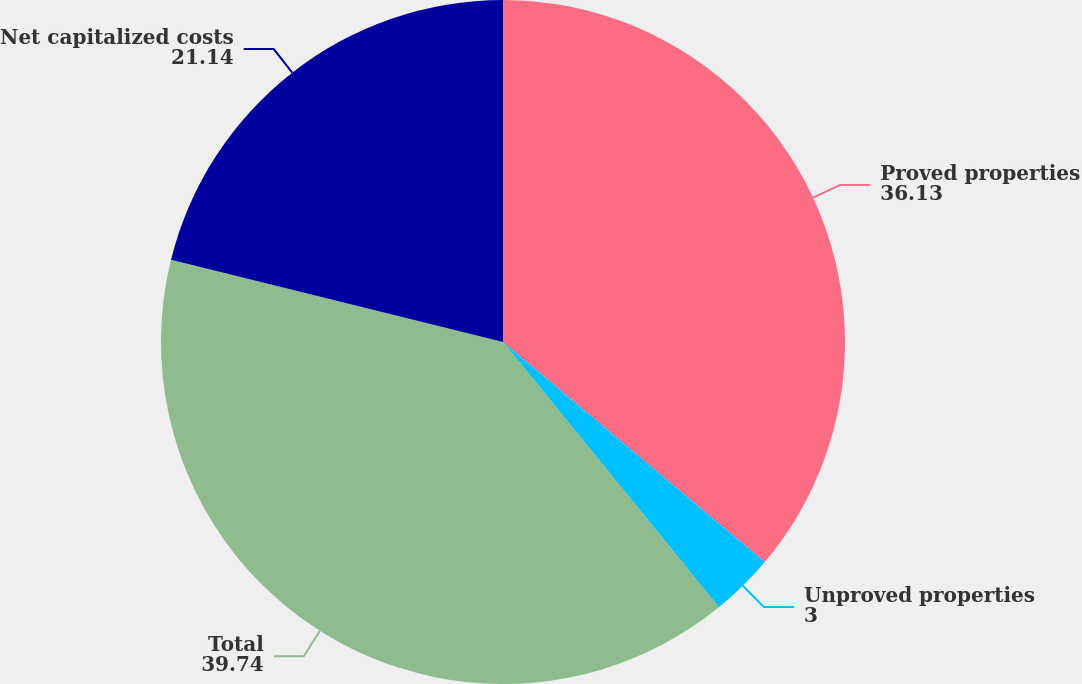<chart> <loc_0><loc_0><loc_500><loc_500><pie_chart><fcel>Proved properties<fcel>Unproved properties<fcel>Total<fcel>Net capitalized costs<nl><fcel>36.13%<fcel>3.0%<fcel>39.74%<fcel>21.14%<nl></chart> 